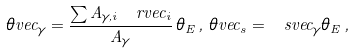Convert formula to latex. <formula><loc_0><loc_0><loc_500><loc_500>\theta v e c _ { \gamma } = \frac { \sum A _ { \gamma , i } \, \ r v e c _ { i } } { A _ { \gamma } } \, \theta _ { E } \, , \, \theta v e c _ { s } = \ s v e c _ { \gamma } \theta _ { E } \, ,</formula> 